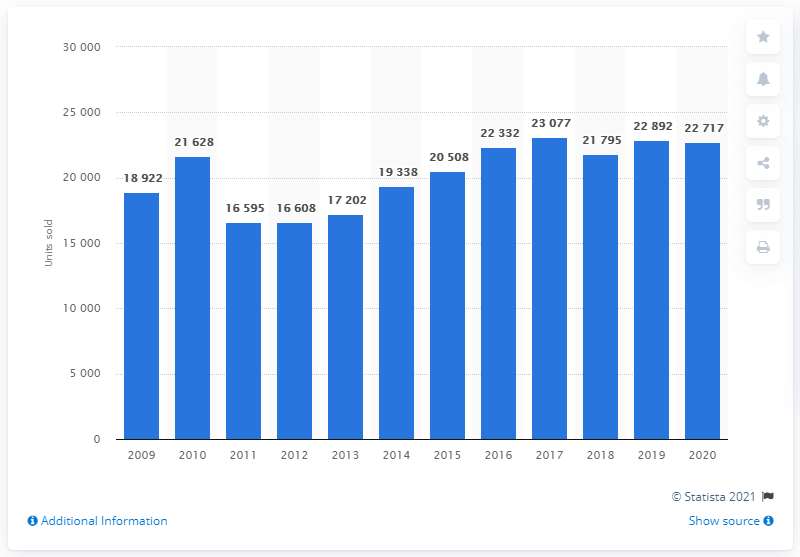Specify some key components in this picture. In the year 2020, a total of 22,700 Toyota cars were sold in Sweden. Between 2009 and 2020, a total of 22,892 Toyota cars were sold in Sweden. 